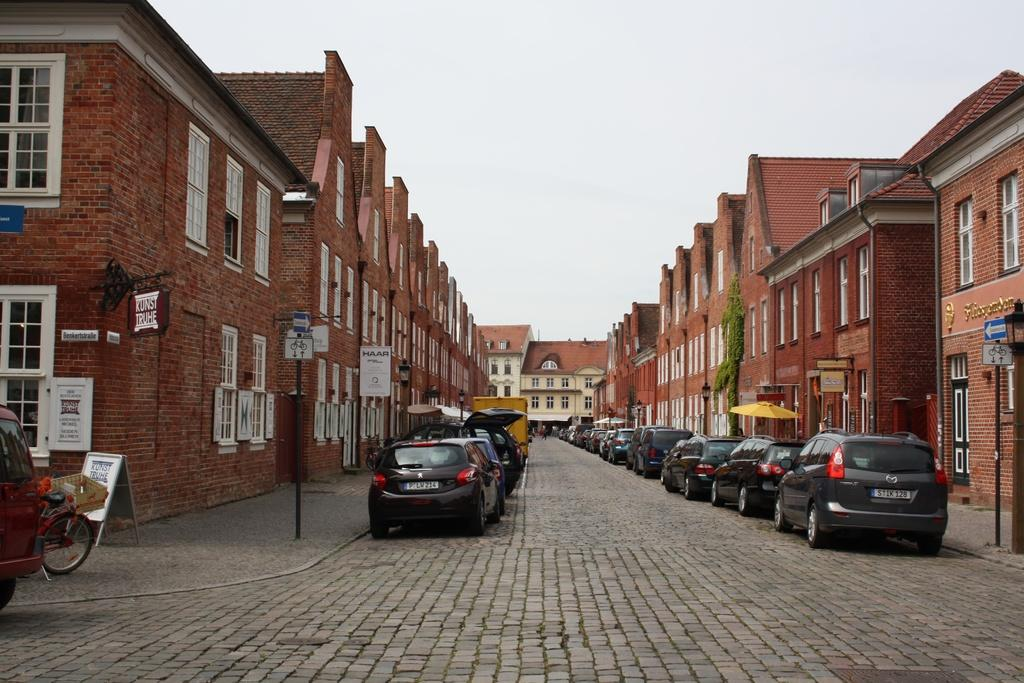What types of man-made structures are visible in the image? There are vehicles, buildings, and poles visible in the image. What else can be seen on the ground in the image? There are other objects on the ground in the image. What is visible in the background of the image? The sky is visible in the background of the image. Can you tell me how many ghosts are visible in the image? There are no ghosts present in the image. What type of secretary can be seen working in the image? There is no secretary present in the image. 